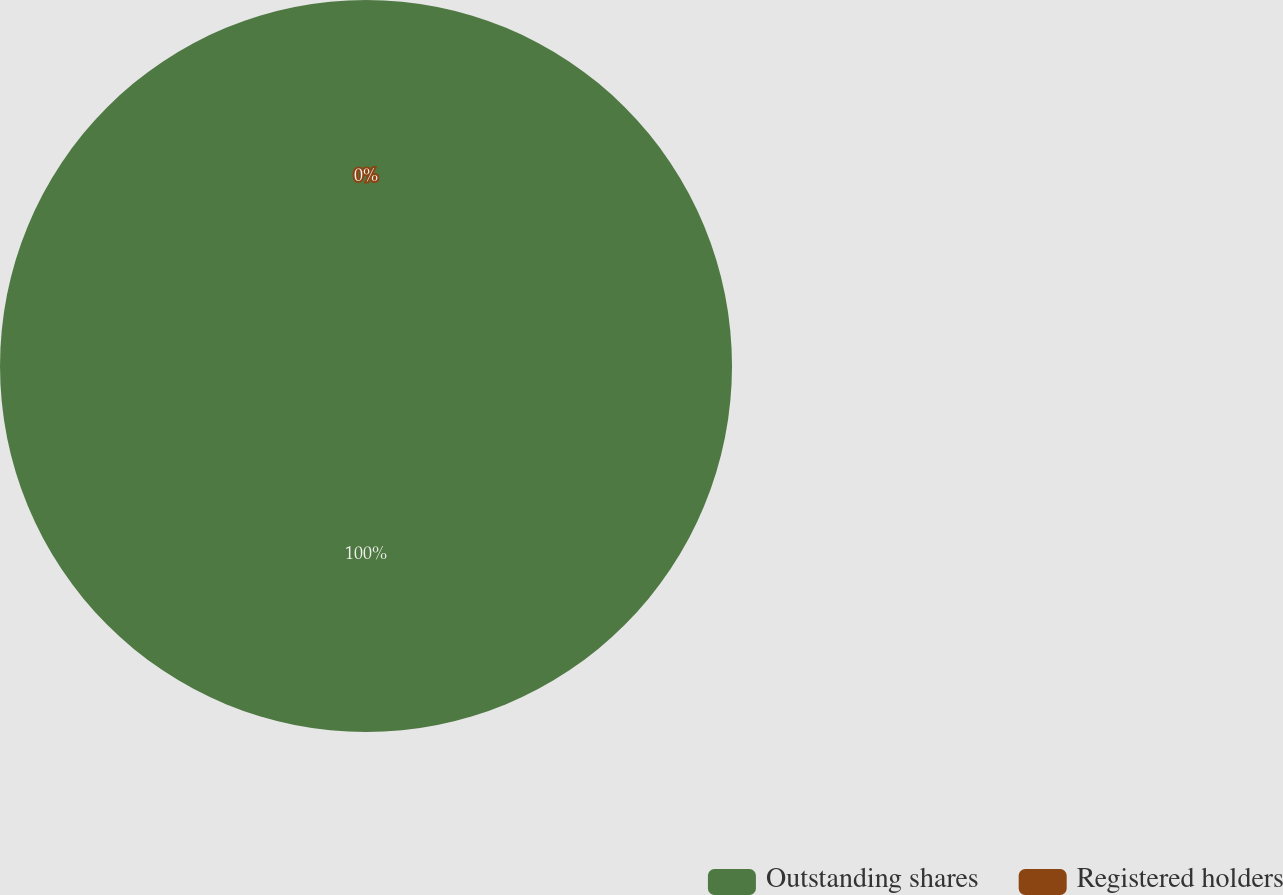Convert chart. <chart><loc_0><loc_0><loc_500><loc_500><pie_chart><fcel>Outstanding shares<fcel>Registered holders<nl><fcel>100.0%<fcel>0.0%<nl></chart> 